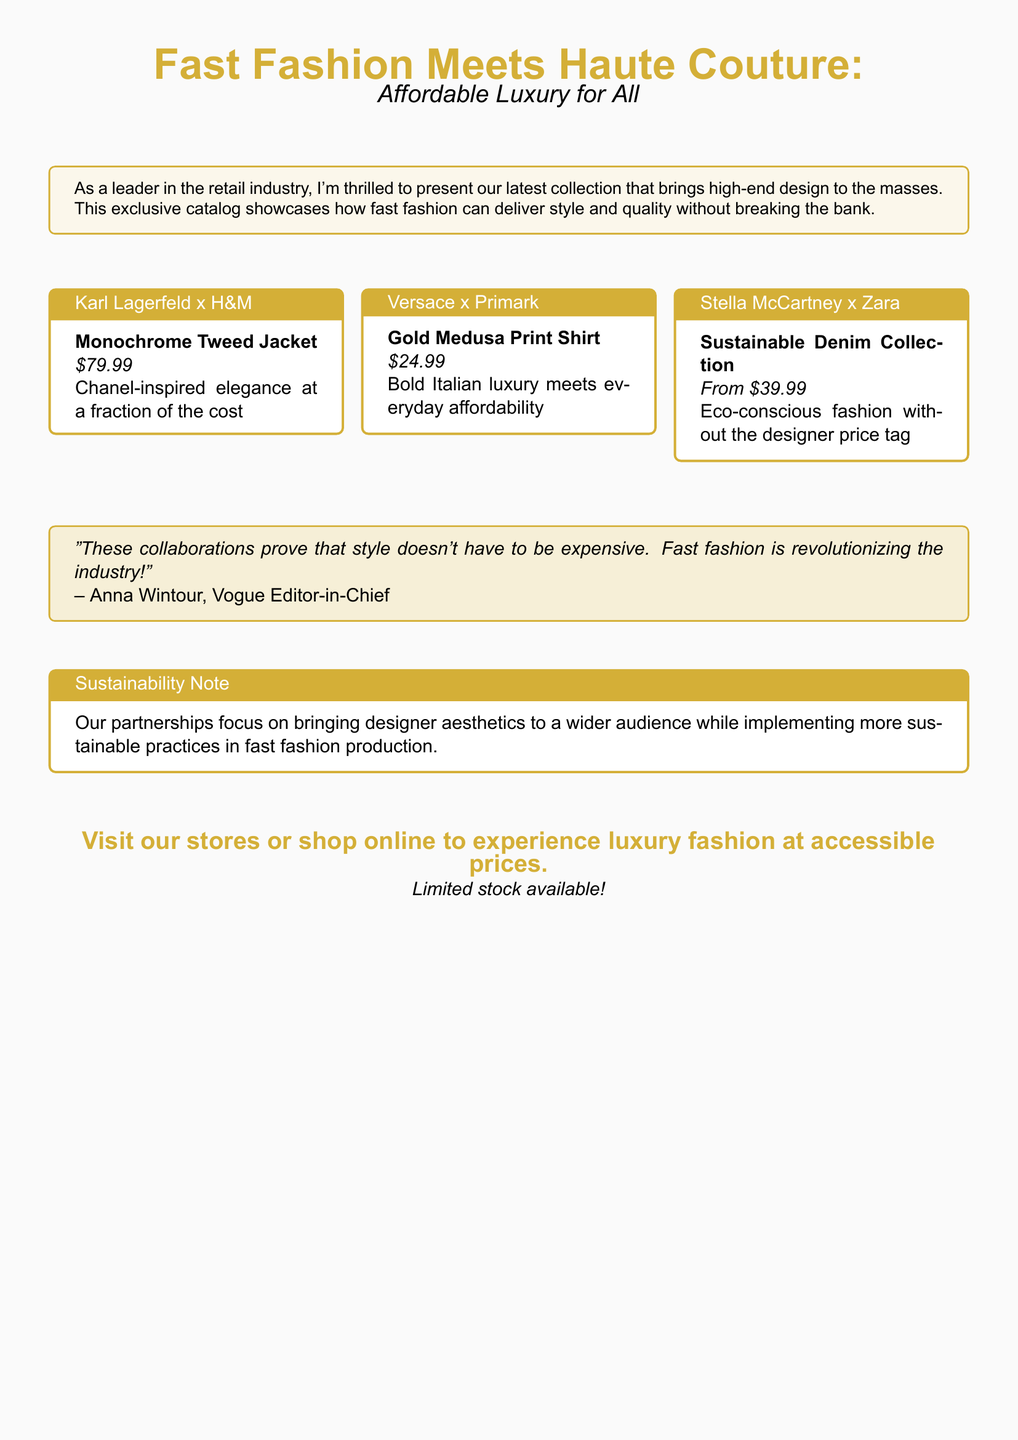What is the title of the catalog? The title of the catalog is prominently displayed at the top as "Fast Fashion Meets Haute Couture: Affordable Luxury for All."
Answer: Fast Fashion Meets Haute Couture: Affordable Luxury for All How much does the Monochrome Tweed Jacket cost? The Monochrome Tweed Jacket is listed at $79.99 in the document.
Answer: $79.99 Which fast fashion brand collaborated with Stella McCartney? The collaboration mentioned for Stella McCartney is with Zara.
Answer: Zara What is the starting price for the Sustainable Denim Collection? The starting price for the Sustainable Denim Collection is indicated as "From $39.99."
Answer: From $39.99 Who is quoted in the document regarding fast fashion? Anna Wintour, Vogue Editor-in-Chief, is quoted about fast fashion in the document.
Answer: Anna Wintour What type of fashion does the Gold Medusa Print Shirt represent? The Gold Medusa Print Shirt represents "Bold Italian luxury meets everyday affordability."
Answer: Bold Italian luxury What sustainability aspect is mentioned in the catalog? The catalog mentions a focus on "more sustainable practices in fast fashion production."
Answer: More sustainable practices How many collaborations are featured in the catalog? There are three collaborations showcased prominently in the document.
Answer: Three What is emphasized as accessible to everyone? The document emphasizes "luxury fashion at accessible prices."
Answer: Luxury fashion at accessible prices 